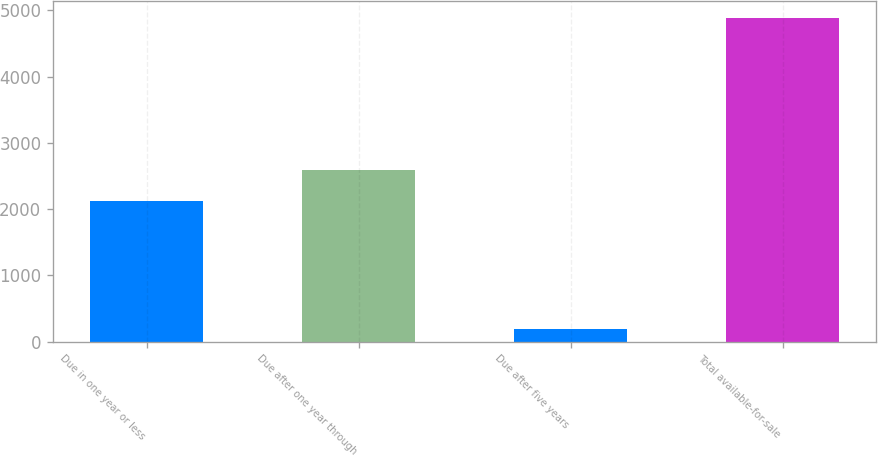<chart> <loc_0><loc_0><loc_500><loc_500><bar_chart><fcel>Due in one year or less<fcel>Due after one year through<fcel>Due after five years<fcel>Total available-for-sale<nl><fcel>2122<fcel>2592.59<fcel>185.3<fcel>4891.2<nl></chart> 